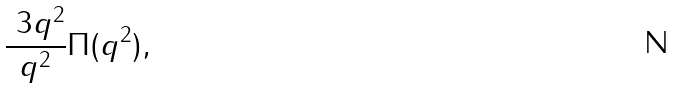<formula> <loc_0><loc_0><loc_500><loc_500>\frac { \ 3 q ^ { 2 } } { q ^ { 2 } } \Pi ( q ^ { 2 } ) ,</formula> 